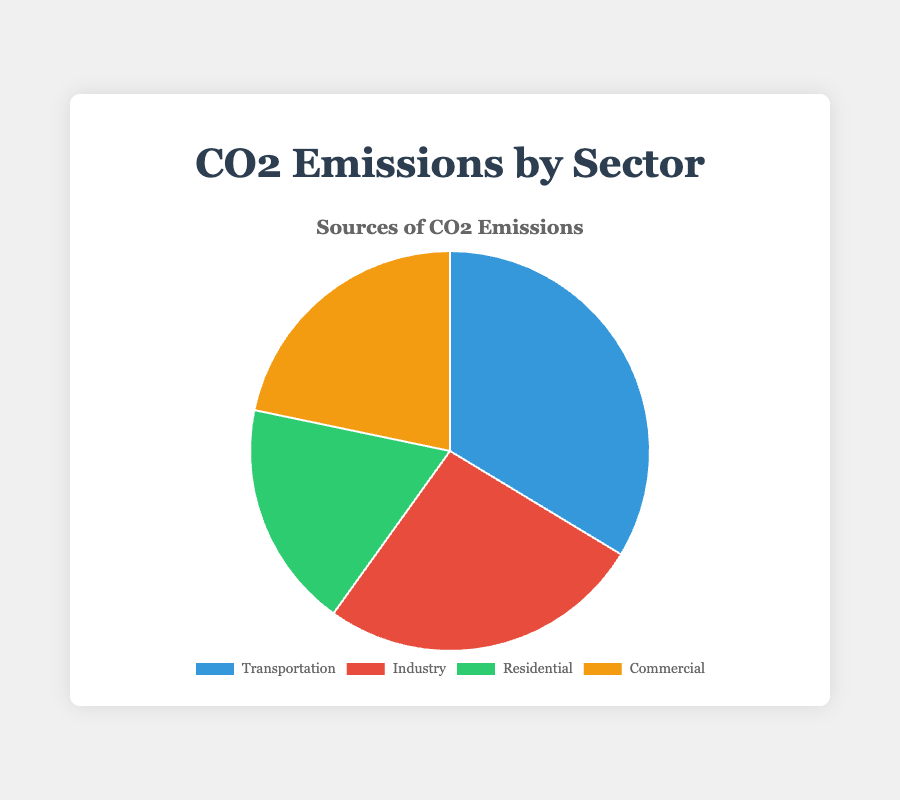Which sector has the highest percentage of CO2 emissions? By observing the chart, identify the sector with the largest slice. Transportation has the highest percentage at 28.2%.
Answer: Transportation Which sector has the lowest percentage of CO2 emissions? By looking at the sectors with smaller slices, determine which is the smallest. Residential has the lowest percentage at 15.4%.
Answer: Residential What is the combined percentage of CO2 emissions from the Residential and Commercial sectors? Add the percentages of Residential (15.4%) and Commercial (18.2%). The combined percentage is 15.4 + 18.2 = 33.6%.
Answer: 33.6% How much greater is the percentage of CO2 emissions from Transportation than from Industry? Subtract the percentage of Industry (22.0%) from Transportation (28.2%). The difference is 28.2 - 22.0 = 6.2%.
Answer: 6.2% If the CO2 emissions from the Transportation sector were reduced by 5%, what would the new percentage be? Subtract 5 from the current Transportation percentage (28.2%). The new percentage would be 28.2 - 5.0 = 23.2%.
Answer: 23.2% What percentage of CO2 emissions does the Commercial sector contribute, rounded to the nearest whole number? The percentage for the Commercial sector is 18.2%. Rounding this to the nearest whole number gives 18%.
Answer: 18% Which sector contributes more CO2 emissions, the Industry or Commercial sector, and by how much? Compare the percentages of Industry (22.0%) and Commercial (18.2%). Industry contributes 22.0 - 18.2 = 3.8% more than the Commercial sector.
Answer: Industry, 3.8% What is the average percentage of CO2 emissions across all four sectors? Add all percentages (28.2, 22.0, 15.4, 18.2) and divide by 4. The average is (28.2 + 22.0 + 15.4 + 18.2) / 4 = 83.8 / 4 = 20.95%.
Answer: 20.95% Which sector's slice is represented by the green color in the pie chart? Identify the sectors by color. Green is used for the Residential sector.
Answer: Residential 